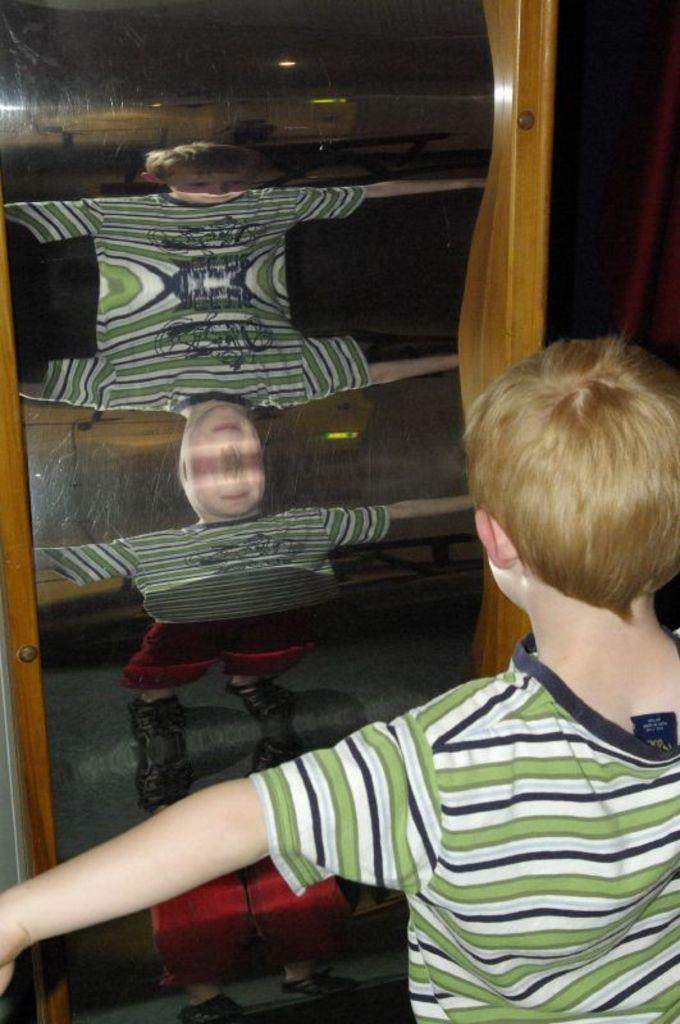Who is the main subject in the image? There is a boy in the image. What is the boy wearing? The boy is wearing a white and green striped t-shirt. What can be seen behind the boy in the image? The boy is standing in front of a crooked mirror. How many icicles are hanging from the boy's t-shirt in the image? There are no icicles present in the image. What type of drug can be seen in the boy's hand in the image? There is no drug visible in the image; the boy is not holding anything in his hand. 